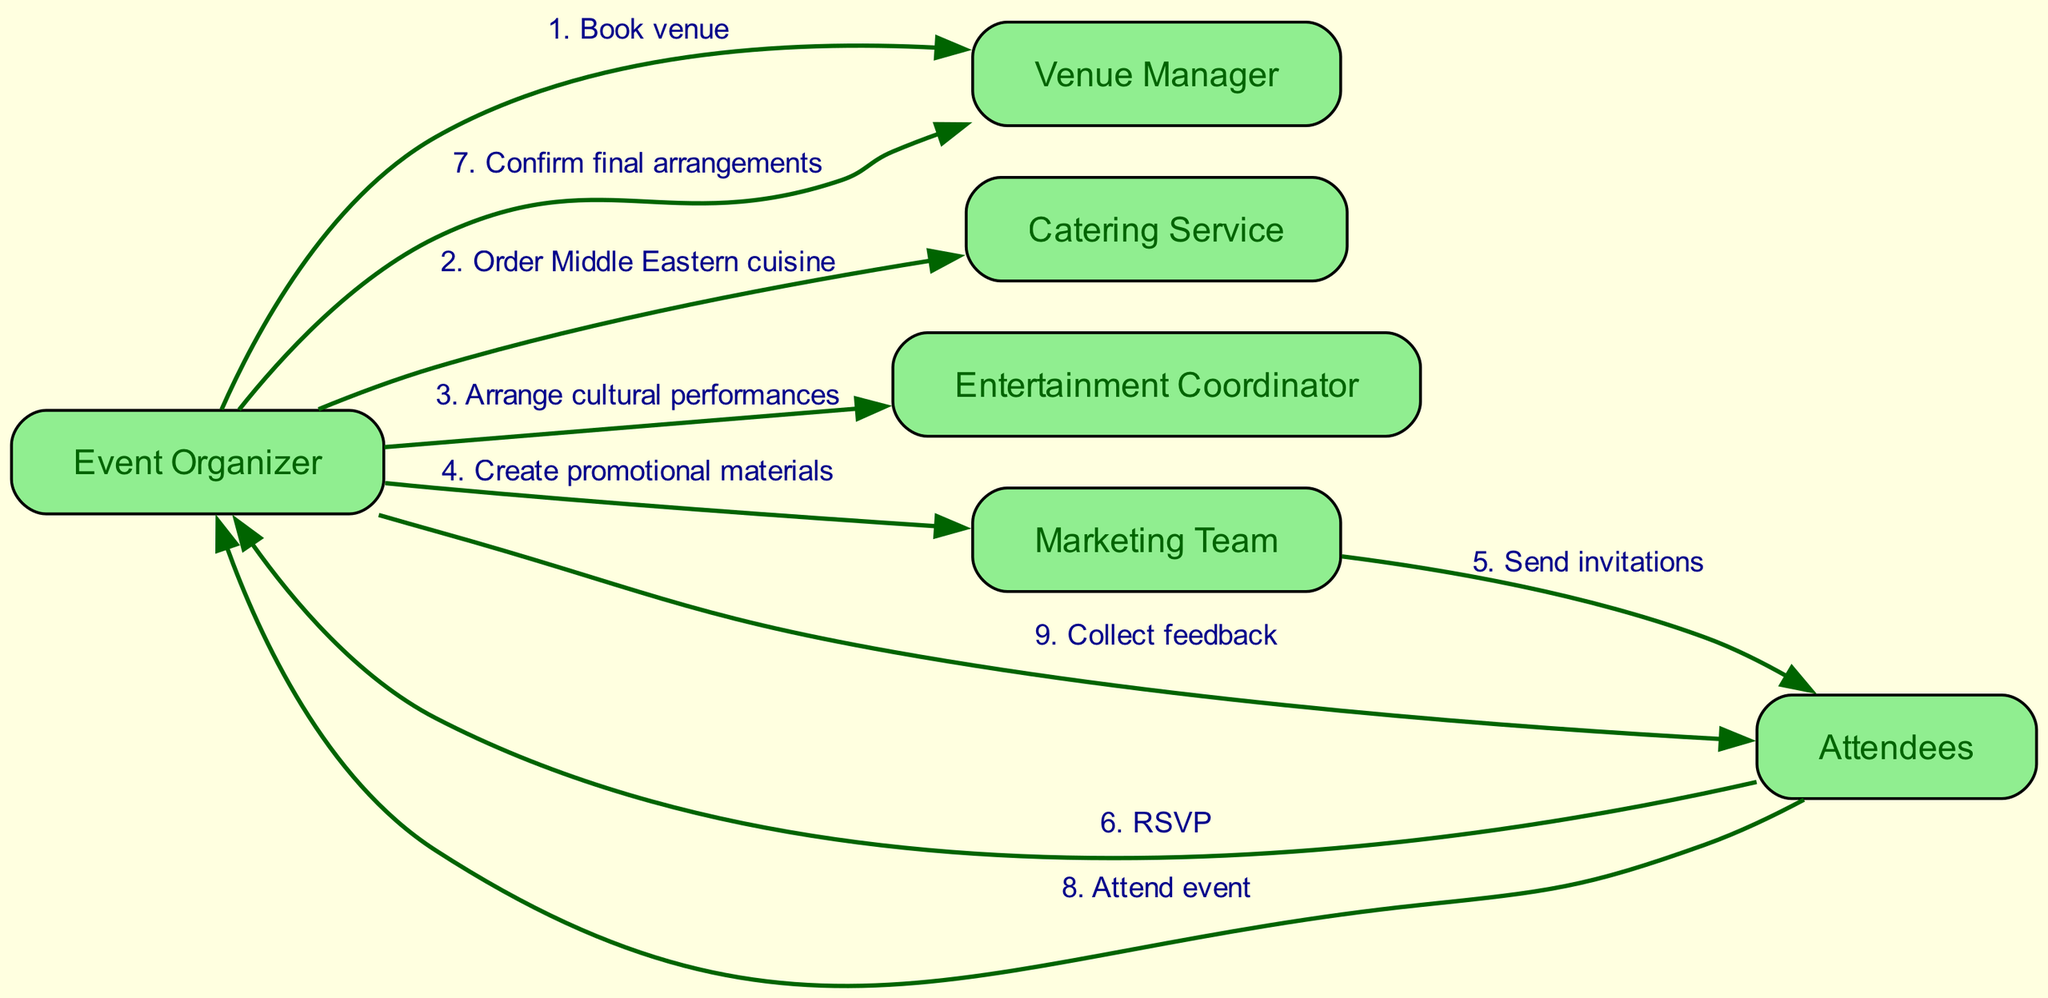What is the first action taken by the Event Organizer? The first action in the sequence from the Event Organizer is to "Book venue." This can be found at the start of the sequence, where the Event Organizer initiates the process.
Answer: Book venue How many actors are involved in the workflow? The diagram lists a total of six actors: Event Organizer, Venue Manager, Catering Service, Entertainment Coordinator, Marketing Team, and Attendees. Adding these actors gives the count.
Answer: Six Which actor sends invitations to attendees? The action that involves sending invitations is performed by the Marketing Team. This step can be identified in the sequence where the Marketing Team communicates with the Attendees.
Answer: Marketing Team What is the last action performed in the sequence? The final action in the sequence is "Collect feedback," which is an action performed by the Event Organizer directed towards the Attendees. It concludes the flow of the event planning process.
Answer: Collect feedback How many steps occur between the ordering of cuisine and sending invitations? There are two steps in between those two actions: first, the Event Organizer orders Middle Eastern cuisine, and then the Marketing Team sends invitations to Attendees. This can be found by counting the actions between those two specific points in the sequence.
Answer: Two Which actor is responsible for confirming final arrangements? The confirmation of final arrangements is done by the Event Organizer, as indicated in the sequence when the Event Organizer communicates with the Venue Manager for the final preparations.
Answer: Event Organizer What is the action taken by Attendees after RSVP? After RSVPing, the Attendees have the action of "Attend event" in the sequence. This indicates their involvement in the event after confirming their participation.
Answer: Attend event How many unique actions are represented in this sequence? The unique actions that are represented in the sequence total eight. Each action is distinct and corresponds to a different step in the cultural event planning process.
Answer: Eight What is the relationship between the Marketing Team and Attendees? The relationship is that the Marketing Team sends invitations to the Attendees. This is depicted in the action where the Marketing Team directly communicates with Attendees in the sequence.
Answer: Send invitations 